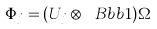Convert formula to latex. <formula><loc_0><loc_0><loc_500><loc_500>\Phi _ { j } = ( U _ { j } \otimes \ B b b { 1 } ) \Omega</formula> 